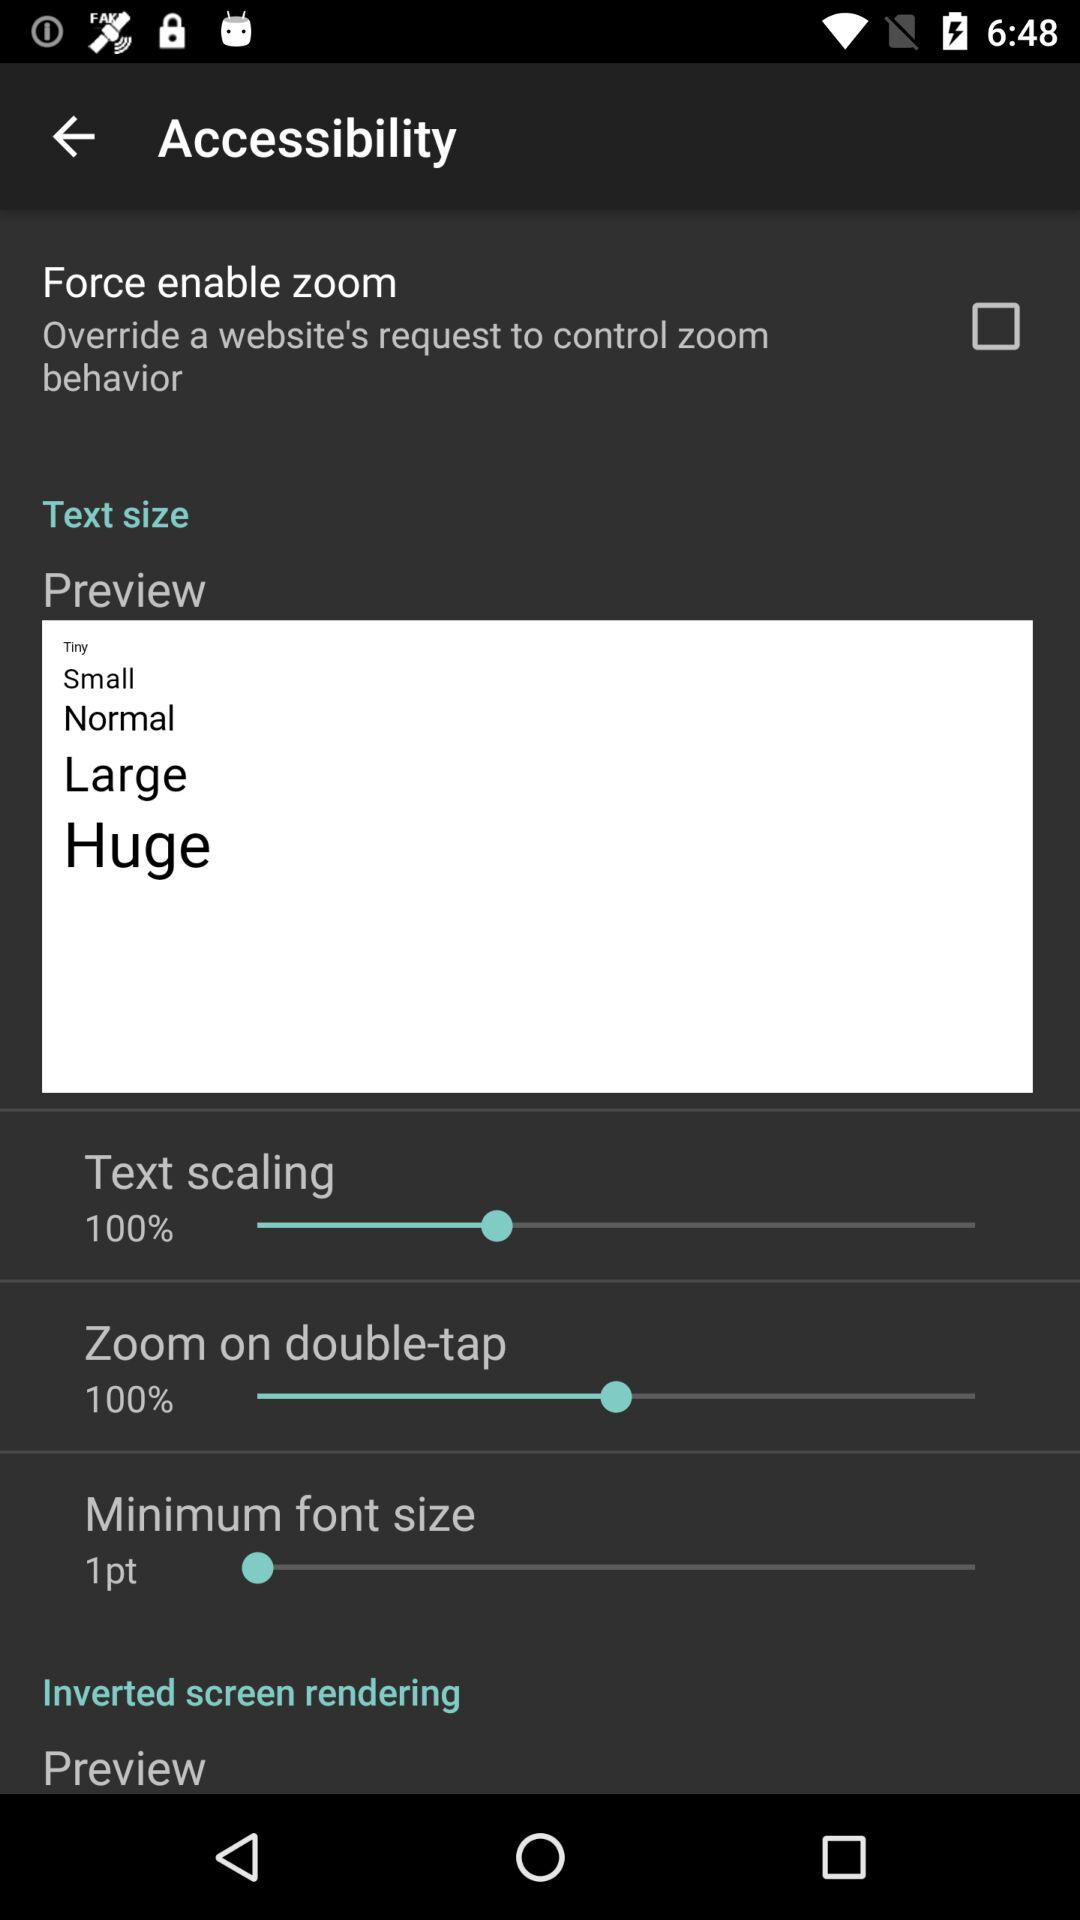What is the minimum font size requirement? The minimum font size requirement is 1 point. 